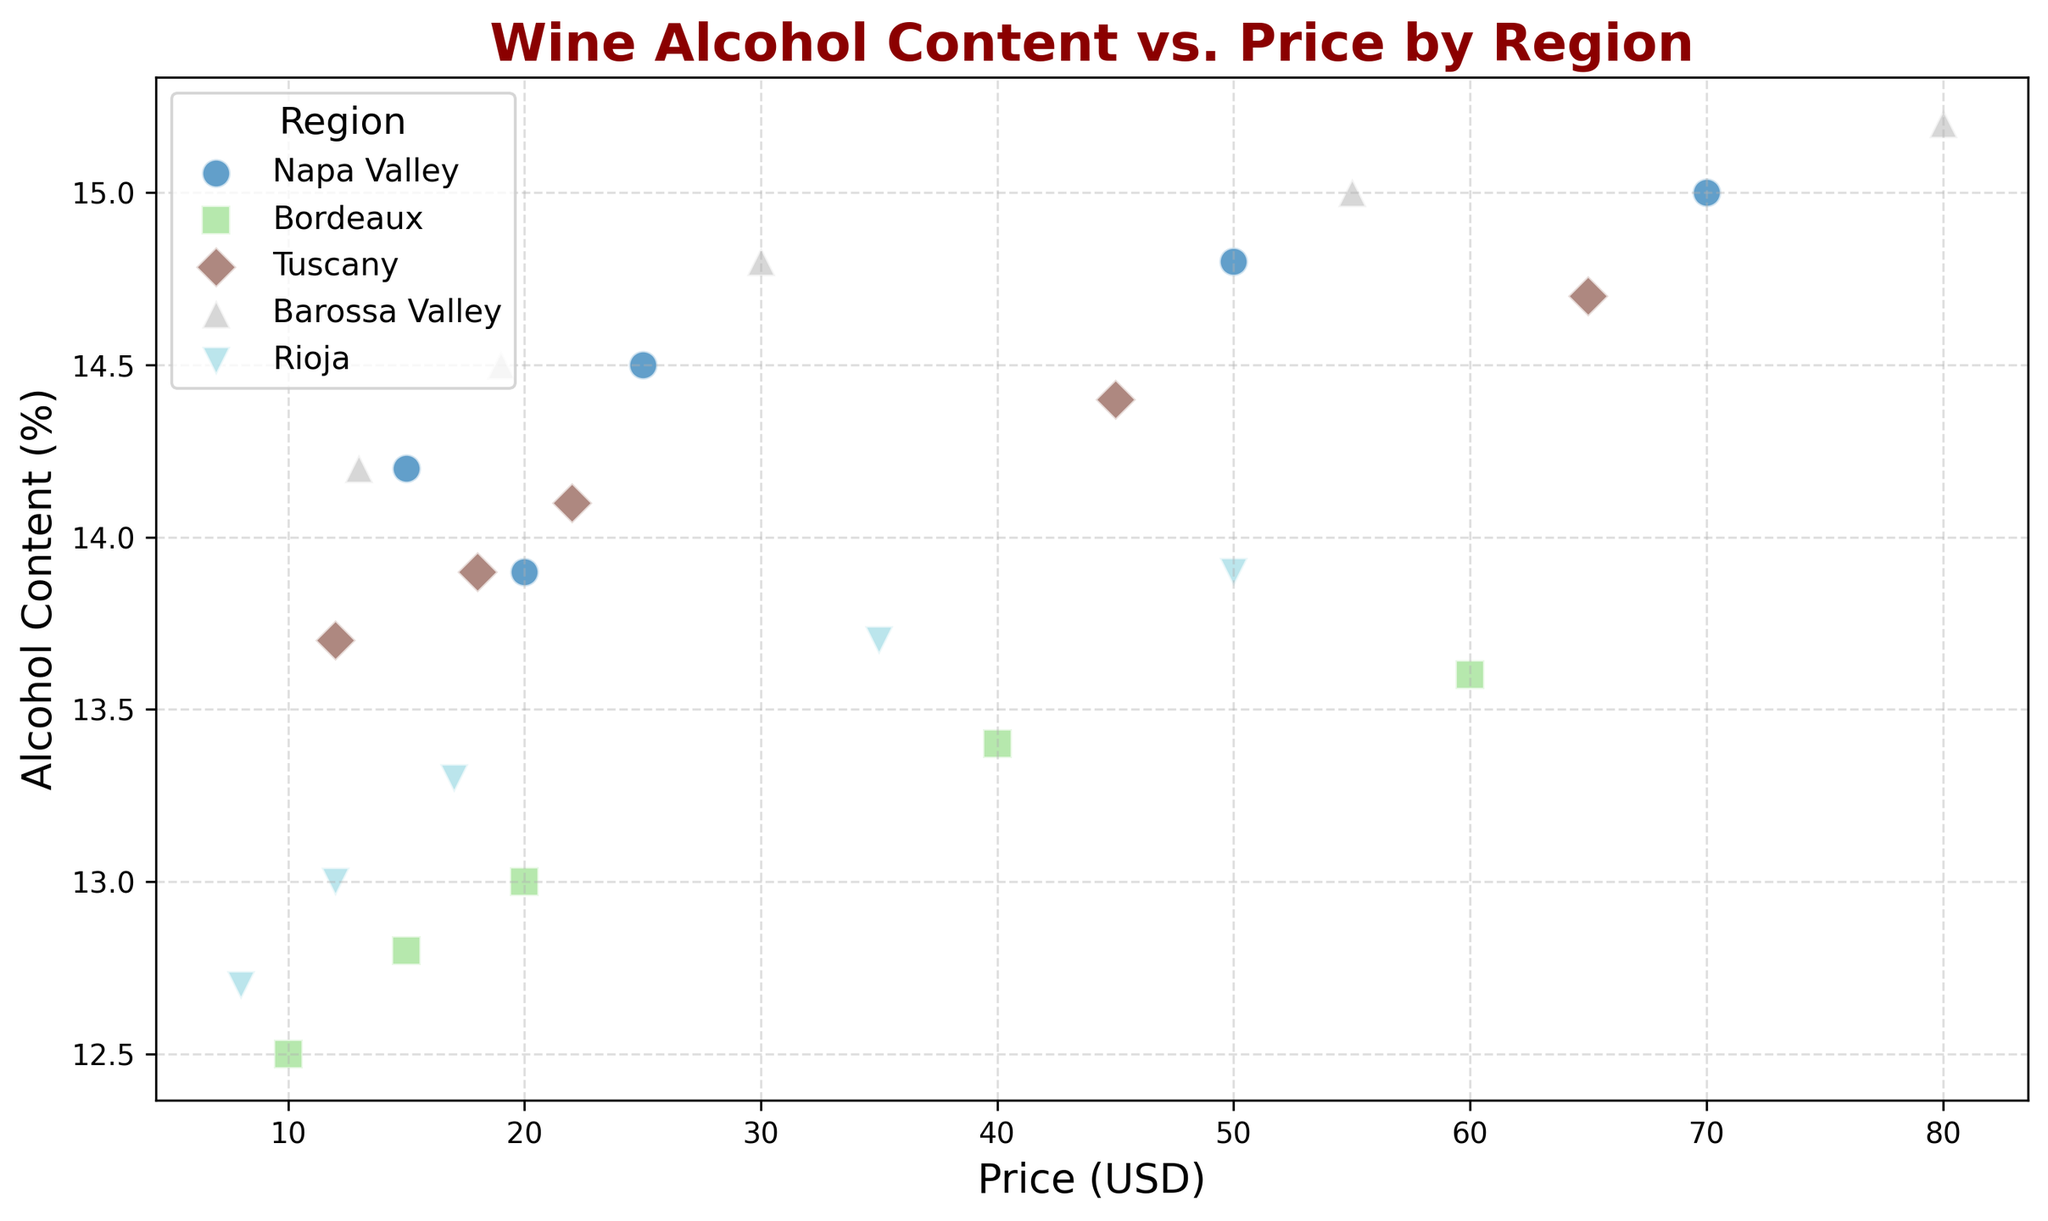What is the highest price point for Napa Valley wines? Identify the dots representing Napa Valley wines and find the one with the highest price value on the x-axis.
Answer: 70.0 USD Which region has the lowest alcohol content in any of its wines? Inspect each region's dots to find the minimum y-axis value for alcohol content. The lowest found is for Bordeaux at 12.5%.
Answer: Bordeaux For wines priced at 20 USD, which region has the highest alcohol content? Look for data points where the price is 20 USD and compare the y-axis (alcohol content) values for each region. Napa Valley has the highest at 13.9%.
Answer: Napa Valley Is there a general trend between price and alcohol content across regions? Analyze the scatter plot to determine if there's an upward or downward trend between price (x-axis) and alcohol content (y-axis). Most regions show an upward trend indicating higher prices tend to have higher alcohol content.
Answer: Higher price generally means higher alcohol content Which region's wines have the most diverse range of alcohol content? Compare the spread of the y-axis values (alcohol content) for each region to see which one has the widest distribution.
Answer: Barossa Valley How does the average alcohol content of Napa Valley wines compare to Bordeaux wines? Calculate the mean alcohol content of Napa Valley and Bordeaux wines and compare. Napa Valley: (14.2 + 13.9 + 14.5 + 14.8 + 15.0) / 5 = 14.48%. Bordeaux: (12.5 + 12.8 + 13.0 + 13.4 + 13.6) / 5 = 13.06%. Napa Valley's average is higher.
Answer: Napa Valley higher Which region has the most expensive wine, and what is its alcohol content? Find the highest value on the x-axis (price) and observe the corresponding region and y-axis (alcohol content) value. The most expensive wine is from Barossa Valley at 80 USD with an alcohol content of 15.2%.
Answer: Barossa Valley, 15.2% At what price point does Tuscany have the lowest alcohol content? Identify the dots representing Tuscany wines and find the one with the lowest y-axis value, then note its x-axis value (price). Tuscany's lowest alcohol content (13.7%) is at 12 USD.
Answer: 12 USD 